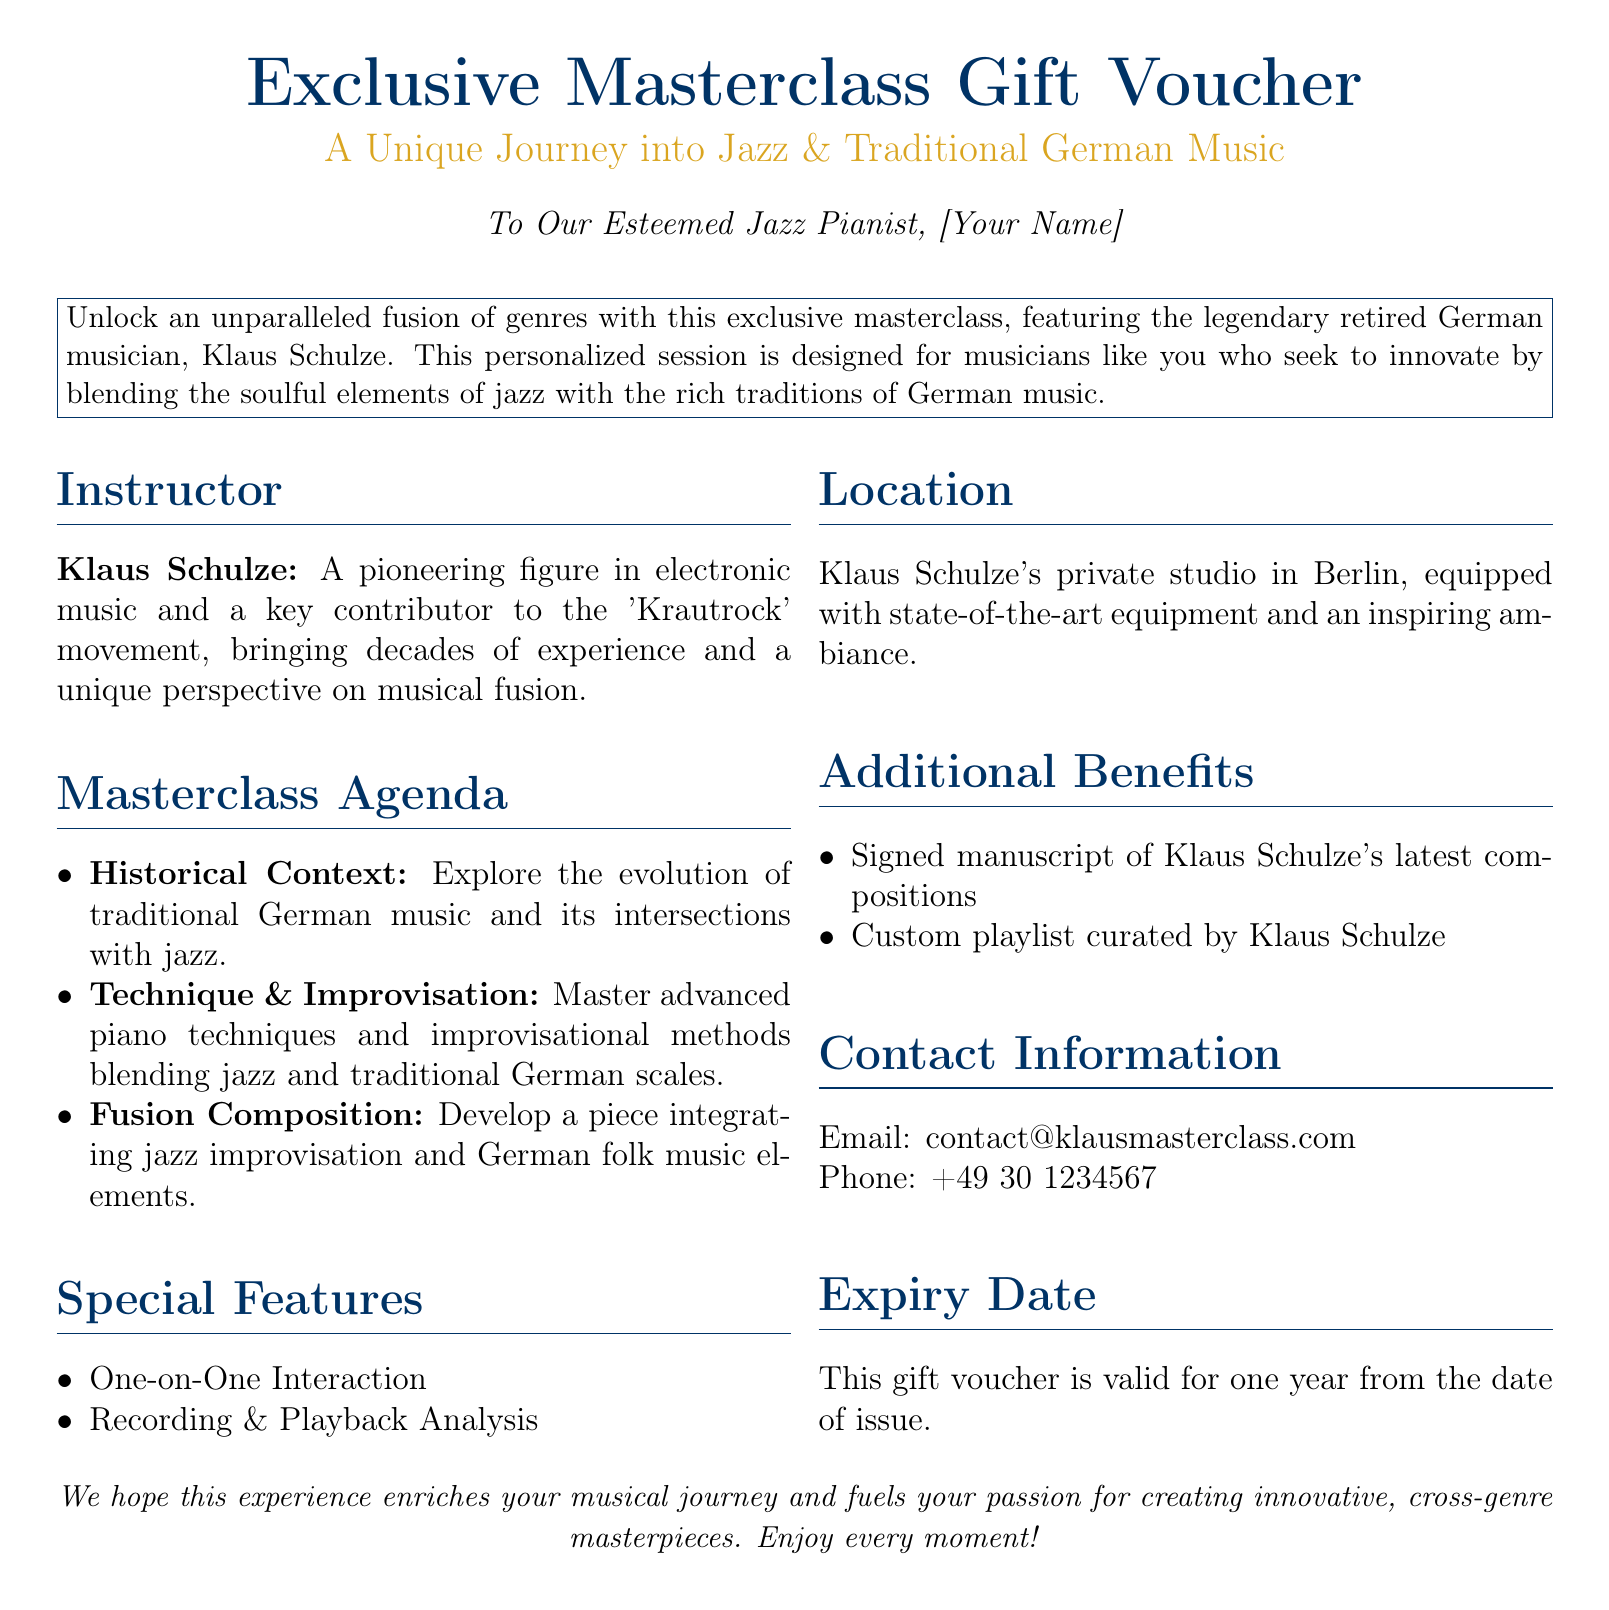What is the name of the instructor? The name of the instructor is mentioned in the "Instructor" section of the document.
Answer: Klaus Schulze What is the location of the masterclass? The location is specified in the "Location" section of the document.
Answer: Berlin What is included in the additional benefits? The "Additional Benefits" section lists what is included, which are two items.
Answer: Signed manuscript and custom playlist What is the expiry duration of the gift voucher? The expiry detail is mentioned under the "Expiry Date" section of the document.
Answer: One year What genre intersections will be explored in the masterclass? The types of music described give insight into the focus areas of the masterclass.
Answer: Jazz and traditional German music What type of teaching method is emphasized in the masterclass? The masterclass agenda indicates the teaching methods used during the class.
Answer: One-on-One Interaction Which musical movement is Klaus Schulze associated with? This information is provided in the "Instructor" section of the document.
Answer: Krautrock What is the email address for contact? The email address is listed under "Contact Information" in the document.
Answer: contact@klausmasterclass.com 